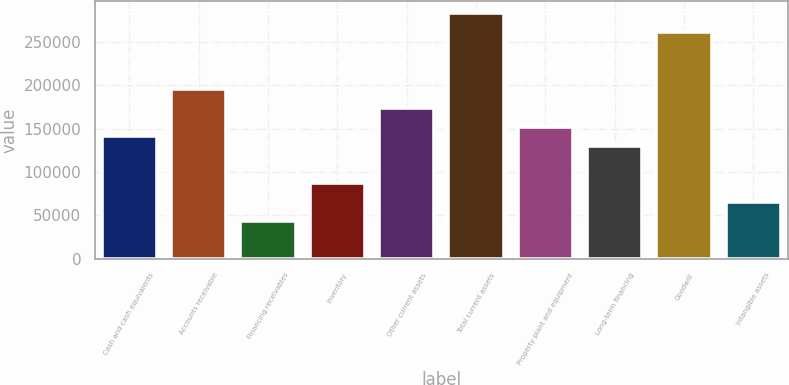Convert chart. <chart><loc_0><loc_0><loc_500><loc_500><bar_chart><fcel>Cash and cash equivalents<fcel>Accounts receivable<fcel>Financing receivables<fcel>Inventory<fcel>Other current assets<fcel>Total current assets<fcel>Property plant and equipment<fcel>Long-term financing<fcel>Goodwill<fcel>Intangible assets<nl><fcel>141392<fcel>195766<fcel>43519.2<fcel>87018.4<fcel>174017<fcel>282765<fcel>152267<fcel>130518<fcel>261015<fcel>65268.8<nl></chart> 